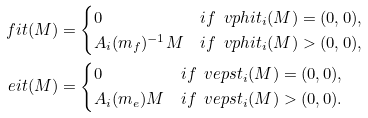<formula> <loc_0><loc_0><loc_500><loc_500>\ f i t ( M ) & = \begin{cases} 0 & i f \ \ v p h i t _ { i } ( M ) = ( 0 , 0 ) , \\ A _ { i } ( m _ { f } ) ^ { - 1 } M & i f \ \ v p h i t _ { i } ( M ) > ( 0 , 0 ) , \end{cases} \\ \ e i t ( M ) & = \begin{cases} 0 & i f \ \ v e p s t _ { i } ( M ) = ( 0 , 0 ) , \\ A _ { i } ( m _ { e } ) M & i f \ \ v e p s t _ { i } ( M ) > ( 0 , 0 ) . \end{cases}</formula> 